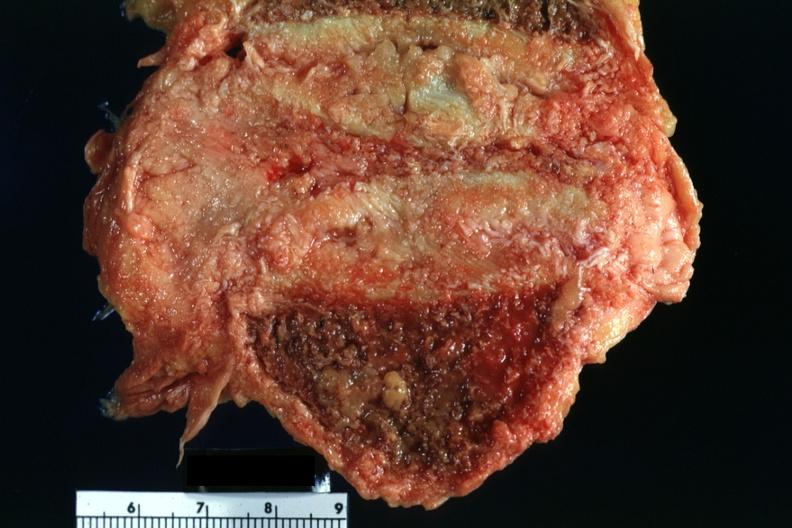does this image show close-up of collapsed vertebral body with tumor rather easily seen?
Answer the question using a single word or phrase. Yes 